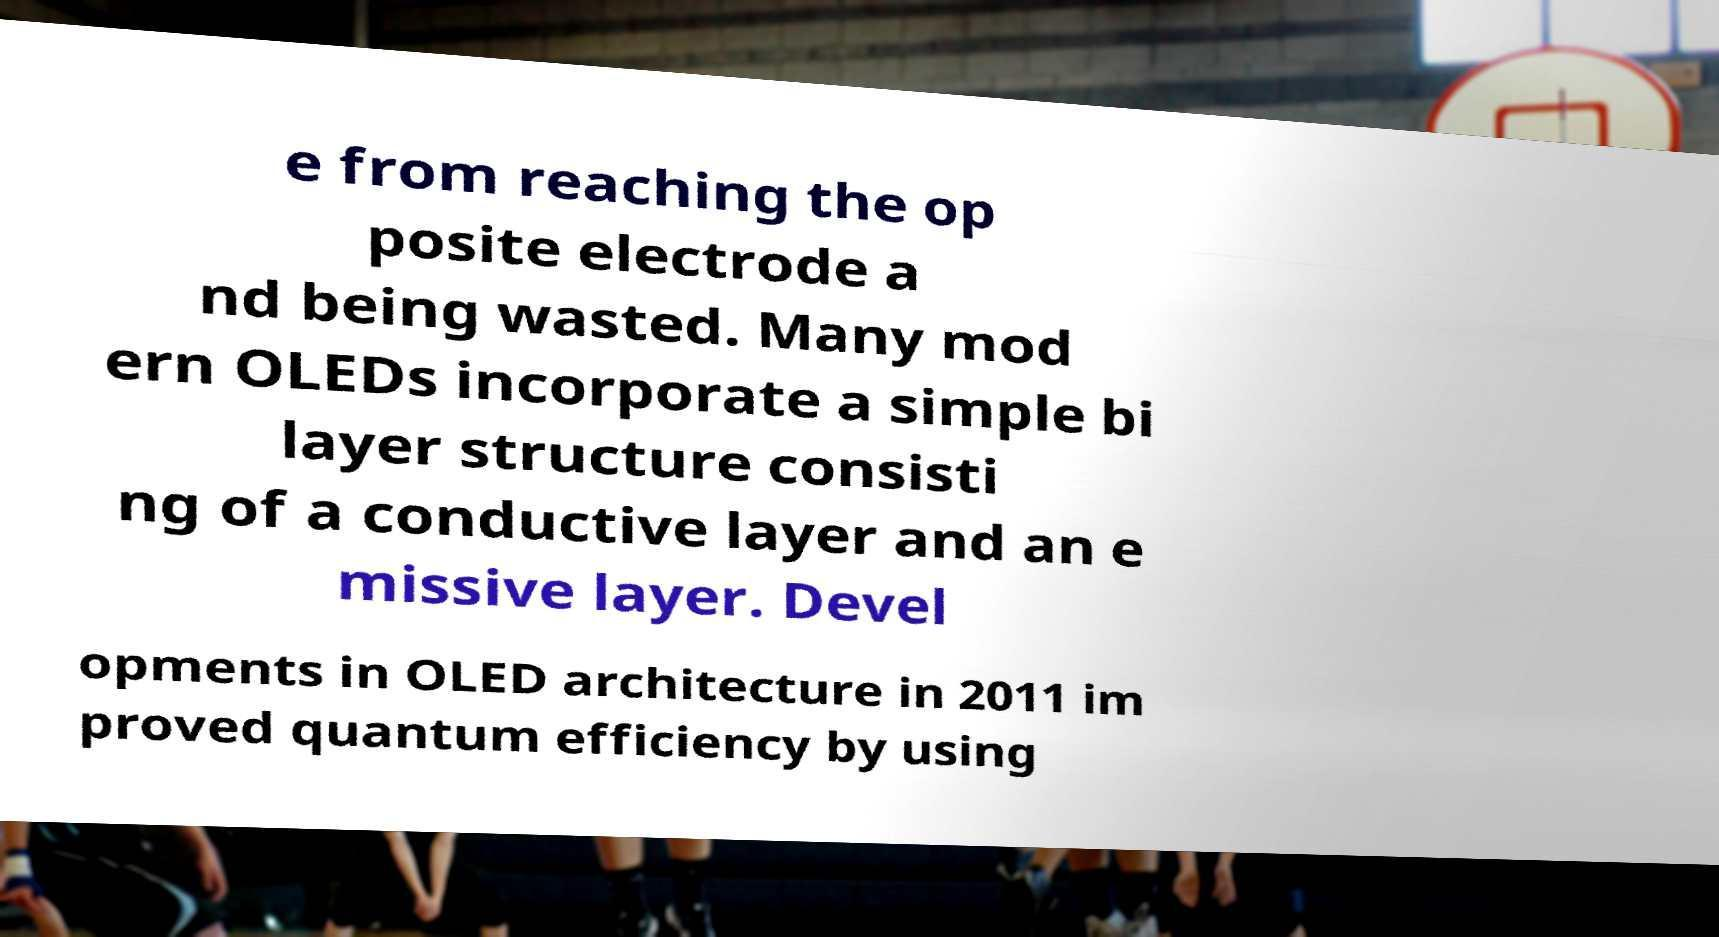Could you assist in decoding the text presented in this image and type it out clearly? e from reaching the op posite electrode a nd being wasted. Many mod ern OLEDs incorporate a simple bi layer structure consisti ng of a conductive layer and an e missive layer. Devel opments in OLED architecture in 2011 im proved quantum efficiency by using 